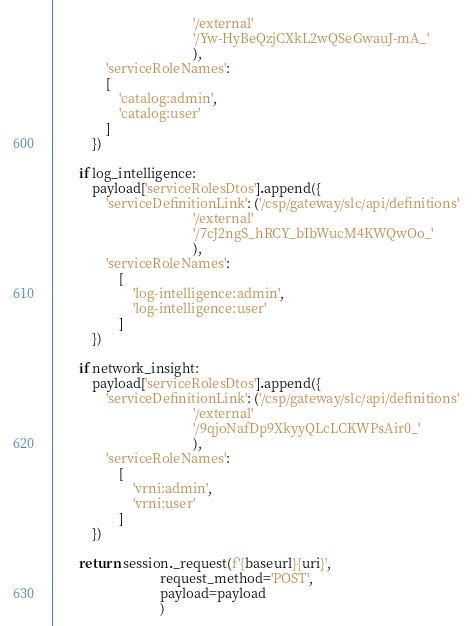Convert code to text. <code><loc_0><loc_0><loc_500><loc_500><_Python_>                                          '/external'
                                          '/Yw-HyBeQzjCXkL2wQSeGwauJ-mA_'
                                          ),
                'serviceRoleNames':
                [
                    'catalog:admin',
                    'catalog:user'
                ]
            })

        if log_intelligence:
            payload['serviceRolesDtos'].append({
                'serviceDefinitionLink': ('/csp/gateway/slc/api/definitions'
                                          '/external'
                                          '/7cJ2ngS_hRCY_bIbWucM4KWQwOo_'
                                          ),
                'serviceRoleNames':
                    [
                        'log-intelligence:admin',
                        'log-intelligence:user'
                    ]
            })

        if network_insight:
            payload['serviceRolesDtos'].append({
                'serviceDefinitionLink': ('/csp/gateway/slc/api/definitions'
                                          '/external'
                                          '/9qjoNafDp9XkyyQLcLCKWPsAir0_'
                                          ),
                'serviceRoleNames':
                    [
                        'vrni:admin',
                        'vrni:user'
                    ]
            })

        return session._request(f'{baseurl}{uri}',
                                request_method='POST',
                                payload=payload
                                )
</code> 